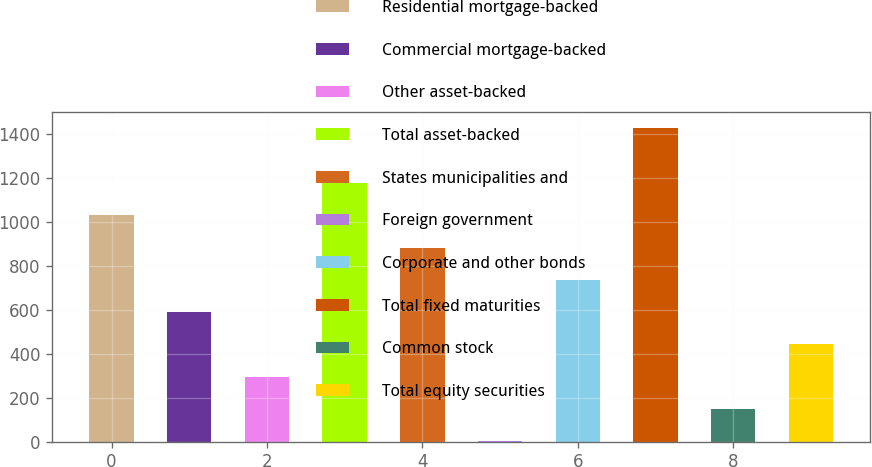Convert chart. <chart><loc_0><loc_0><loc_500><loc_500><bar_chart><fcel>Residential mortgage-backed<fcel>Commercial mortgage-backed<fcel>Other asset-backed<fcel>Total asset-backed<fcel>States municipalities and<fcel>Foreign government<fcel>Corporate and other bonds<fcel>Total fixed maturities<fcel>Common stock<fcel>Total equity securities<nl><fcel>1031.7<fcel>590.4<fcel>296.2<fcel>1178.8<fcel>884.6<fcel>2<fcel>737.5<fcel>1430<fcel>149.1<fcel>443.3<nl></chart> 